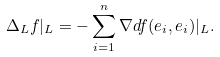Convert formula to latex. <formula><loc_0><loc_0><loc_500><loc_500>\Delta _ { L } f | _ { L } = - \sum _ { i = 1 } ^ { n } \nabla d f ( e _ { i } , e _ { i } ) | _ { L } .</formula> 